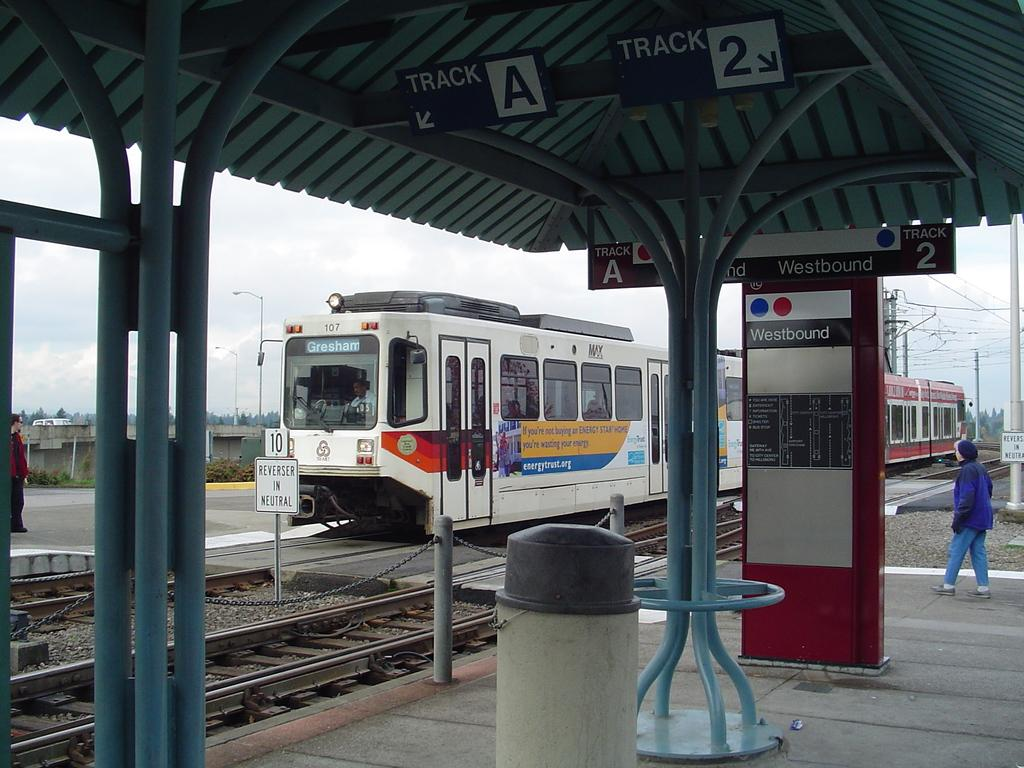<image>
Write a terse but informative summary of the picture. the word westbound that is on a sign 